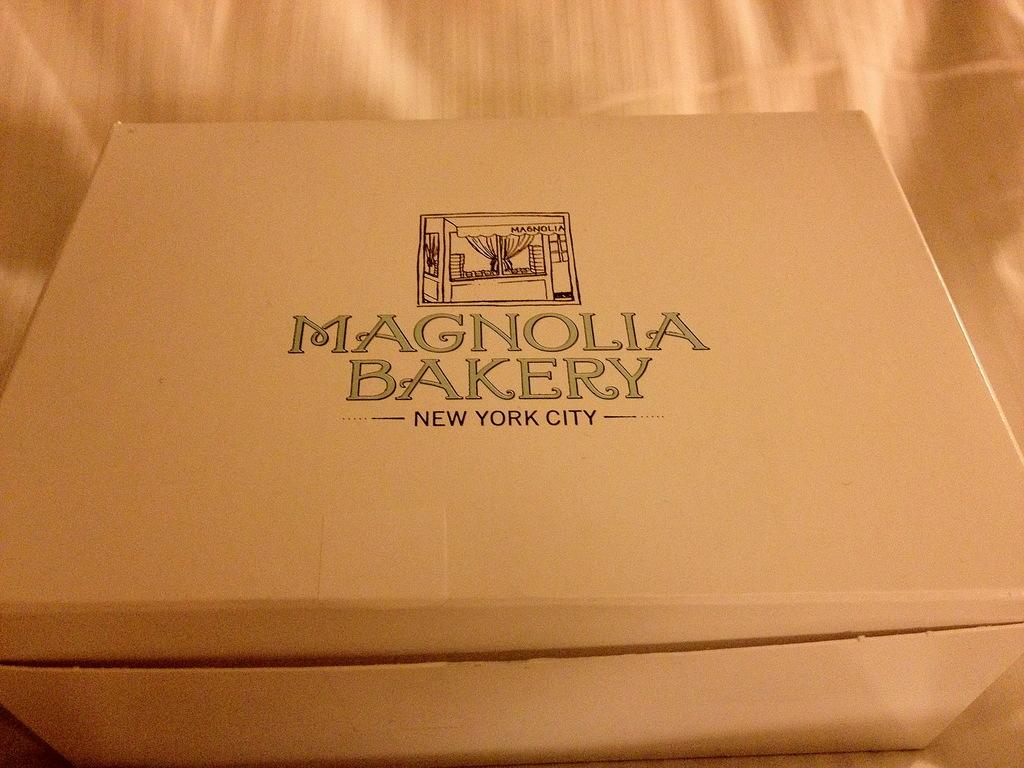<image>
Create a compact narrative representing the image presented. Box for Magnolia Bakery in New York City. 